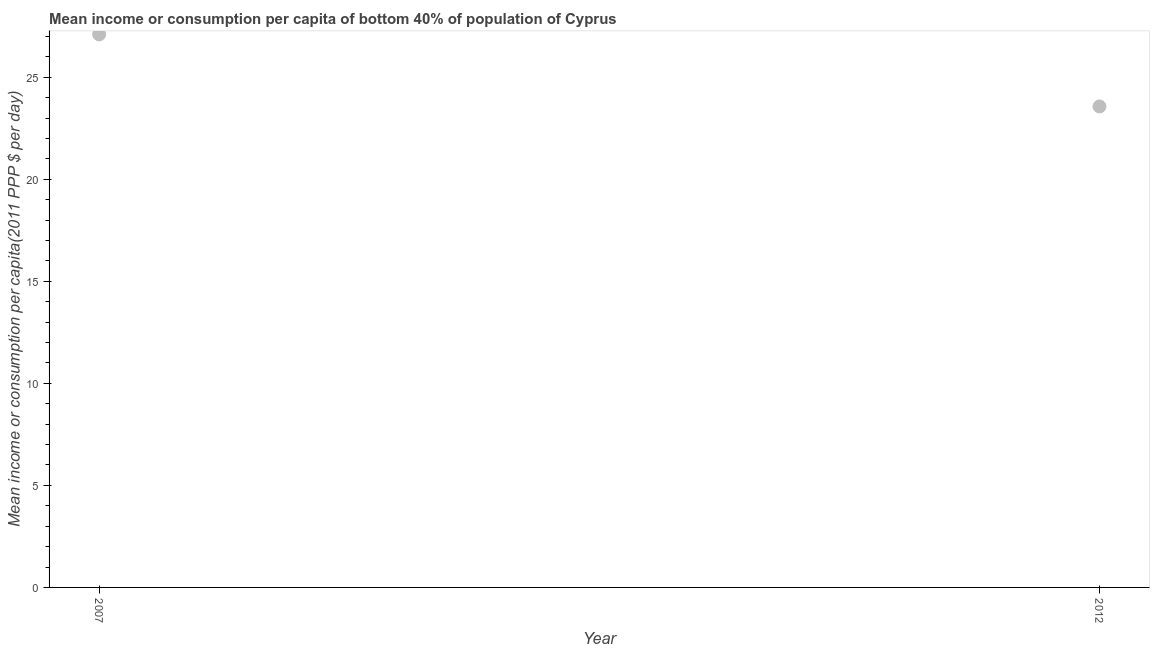What is the mean income or consumption in 2012?
Provide a succinct answer. 23.57. Across all years, what is the maximum mean income or consumption?
Your answer should be compact. 27.1. Across all years, what is the minimum mean income or consumption?
Keep it short and to the point. 23.57. In which year was the mean income or consumption maximum?
Your answer should be compact. 2007. In which year was the mean income or consumption minimum?
Provide a succinct answer. 2012. What is the sum of the mean income or consumption?
Make the answer very short. 50.67. What is the difference between the mean income or consumption in 2007 and 2012?
Give a very brief answer. 3.53. What is the average mean income or consumption per year?
Offer a very short reply. 25.34. What is the median mean income or consumption?
Give a very brief answer. 25.34. Do a majority of the years between 2007 and 2012 (inclusive) have mean income or consumption greater than 26 $?
Offer a terse response. No. What is the ratio of the mean income or consumption in 2007 to that in 2012?
Your answer should be compact. 1.15. In how many years, is the mean income or consumption greater than the average mean income or consumption taken over all years?
Give a very brief answer. 1. Does the mean income or consumption monotonically increase over the years?
Keep it short and to the point. No. How many years are there in the graph?
Ensure brevity in your answer.  2. Does the graph contain grids?
Provide a succinct answer. No. What is the title of the graph?
Offer a terse response. Mean income or consumption per capita of bottom 40% of population of Cyprus. What is the label or title of the Y-axis?
Your response must be concise. Mean income or consumption per capita(2011 PPP $ per day). What is the Mean income or consumption per capita(2011 PPP $ per day) in 2007?
Give a very brief answer. 27.1. What is the Mean income or consumption per capita(2011 PPP $ per day) in 2012?
Offer a terse response. 23.57. What is the difference between the Mean income or consumption per capita(2011 PPP $ per day) in 2007 and 2012?
Your answer should be very brief. 3.53. What is the ratio of the Mean income or consumption per capita(2011 PPP $ per day) in 2007 to that in 2012?
Provide a succinct answer. 1.15. 